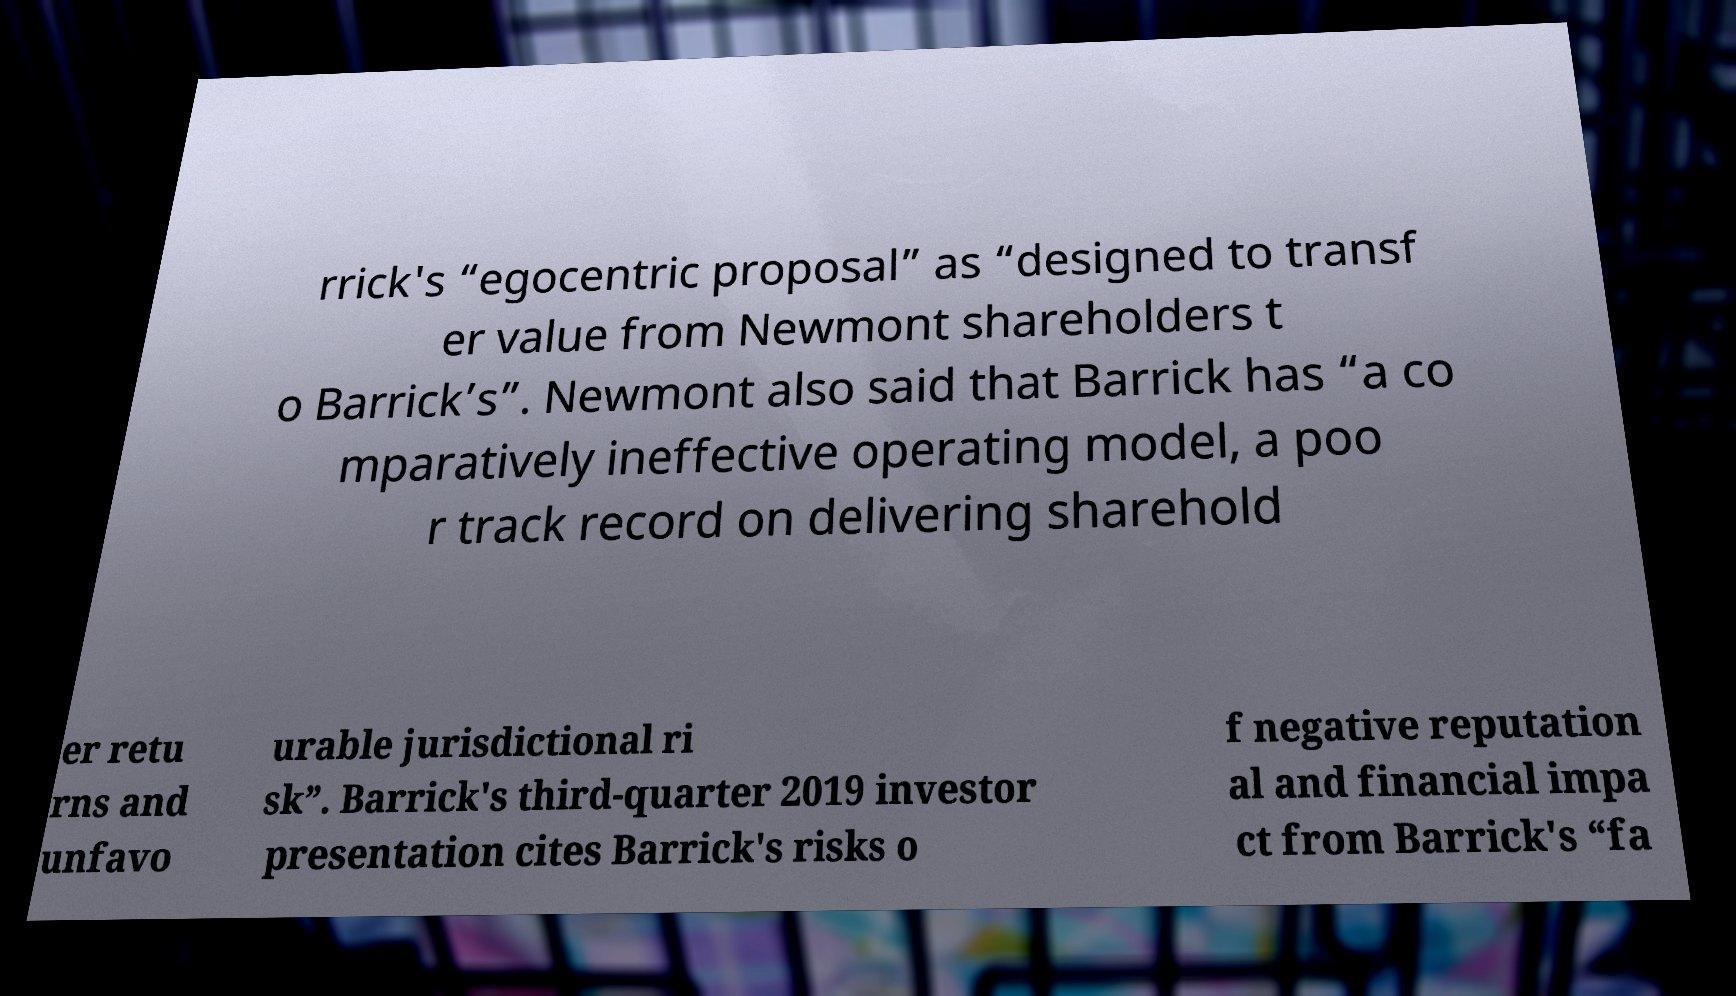Can you read and provide the text displayed in the image?This photo seems to have some interesting text. Can you extract and type it out for me? rrick's “egocentric proposal” as “designed to transf er value from Newmont shareholders t o Barrick’s”. Newmont also said that Barrick has “a co mparatively ineffective operating model, a poo r track record on delivering sharehold er retu rns and unfavo urable jurisdictional ri sk”. Barrick's third-quarter 2019 investor presentation cites Barrick's risks o f negative reputation al and financial impa ct from Barrick's “fa 